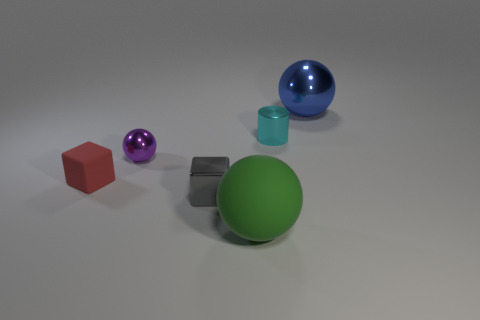Subtract all green rubber balls. How many balls are left? 2 Subtract all green balls. How many balls are left? 2 Subtract 1 spheres. How many spheres are left? 2 Add 3 blue matte cubes. How many objects exist? 9 Subtract 0 purple cylinders. How many objects are left? 6 Subtract all cylinders. How many objects are left? 5 Subtract all blue cylinders. Subtract all purple spheres. How many cylinders are left? 1 Subtract all green rubber things. Subtract all small cyan metal cylinders. How many objects are left? 4 Add 4 rubber things. How many rubber things are left? 6 Add 4 blue metallic things. How many blue metallic things exist? 5 